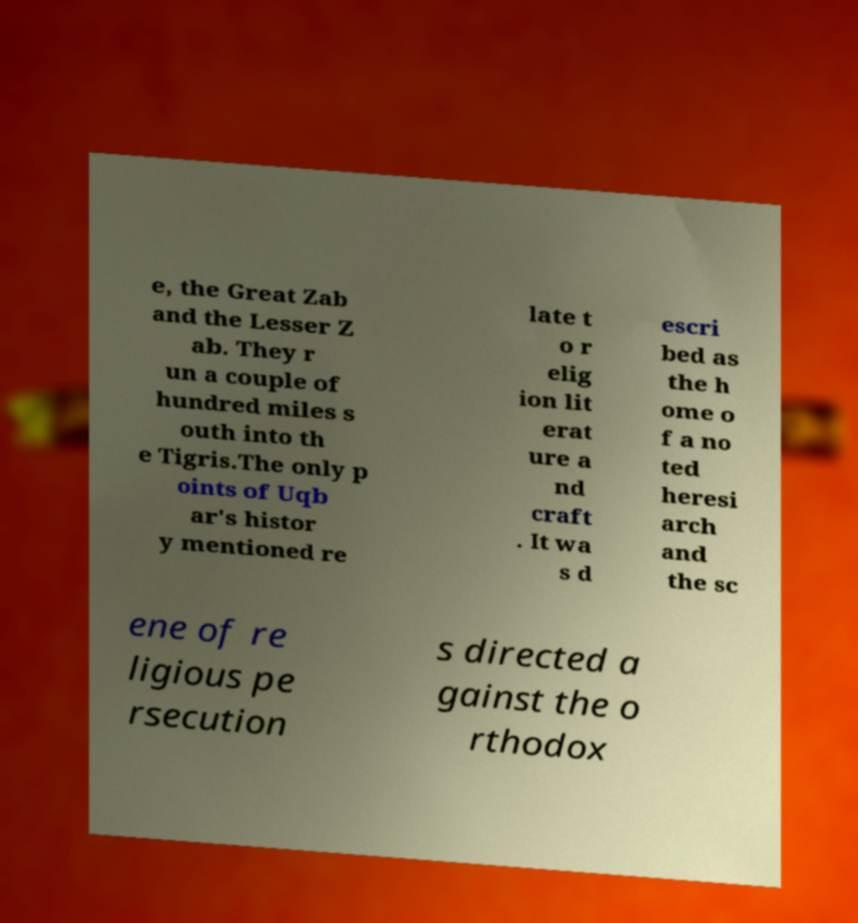There's text embedded in this image that I need extracted. Can you transcribe it verbatim? e, the Great Zab and the Lesser Z ab. They r un a couple of hundred miles s outh into th e Tigris.The only p oints of Uqb ar's histor y mentioned re late t o r elig ion lit erat ure a nd craft . It wa s d escri bed as the h ome o f a no ted heresi arch and the sc ene of re ligious pe rsecution s directed a gainst the o rthodox 